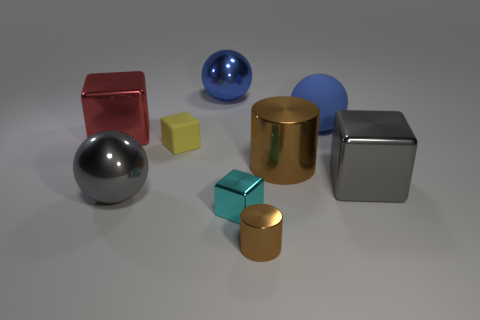Add 3 blue matte balls. How many blue matte balls exist? 4 Add 1 rubber cubes. How many objects exist? 10 Subtract all gray balls. How many balls are left? 2 Subtract all metallic cubes. How many cubes are left? 1 Subtract 1 blue balls. How many objects are left? 8 Subtract all balls. How many objects are left? 6 Subtract 2 balls. How many balls are left? 1 Subtract all cyan cylinders. Subtract all cyan blocks. How many cylinders are left? 2 Subtract all green blocks. How many red balls are left? 0 Subtract all brown things. Subtract all big blue objects. How many objects are left? 5 